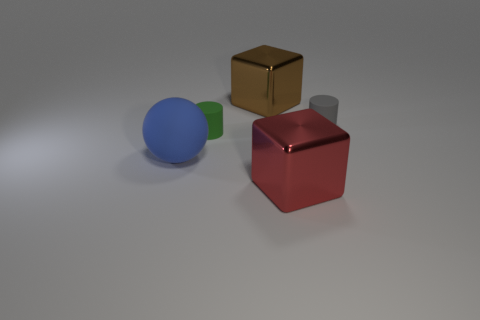Subtract all green cylinders. Subtract all green blocks. How many cylinders are left? 1 Add 3 brown shiny objects. How many objects exist? 8 Subtract all cylinders. How many objects are left? 3 Subtract 0 cyan spheres. How many objects are left? 5 Subtract all small gray rubber cylinders. Subtract all tiny rubber cylinders. How many objects are left? 2 Add 4 large brown metallic objects. How many large brown metallic objects are left? 5 Add 5 large things. How many large things exist? 8 